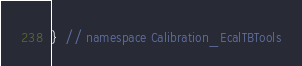<code> <loc_0><loc_0><loc_500><loc_500><_C_>}  // namespace Calibration_EcalTBTools
</code> 